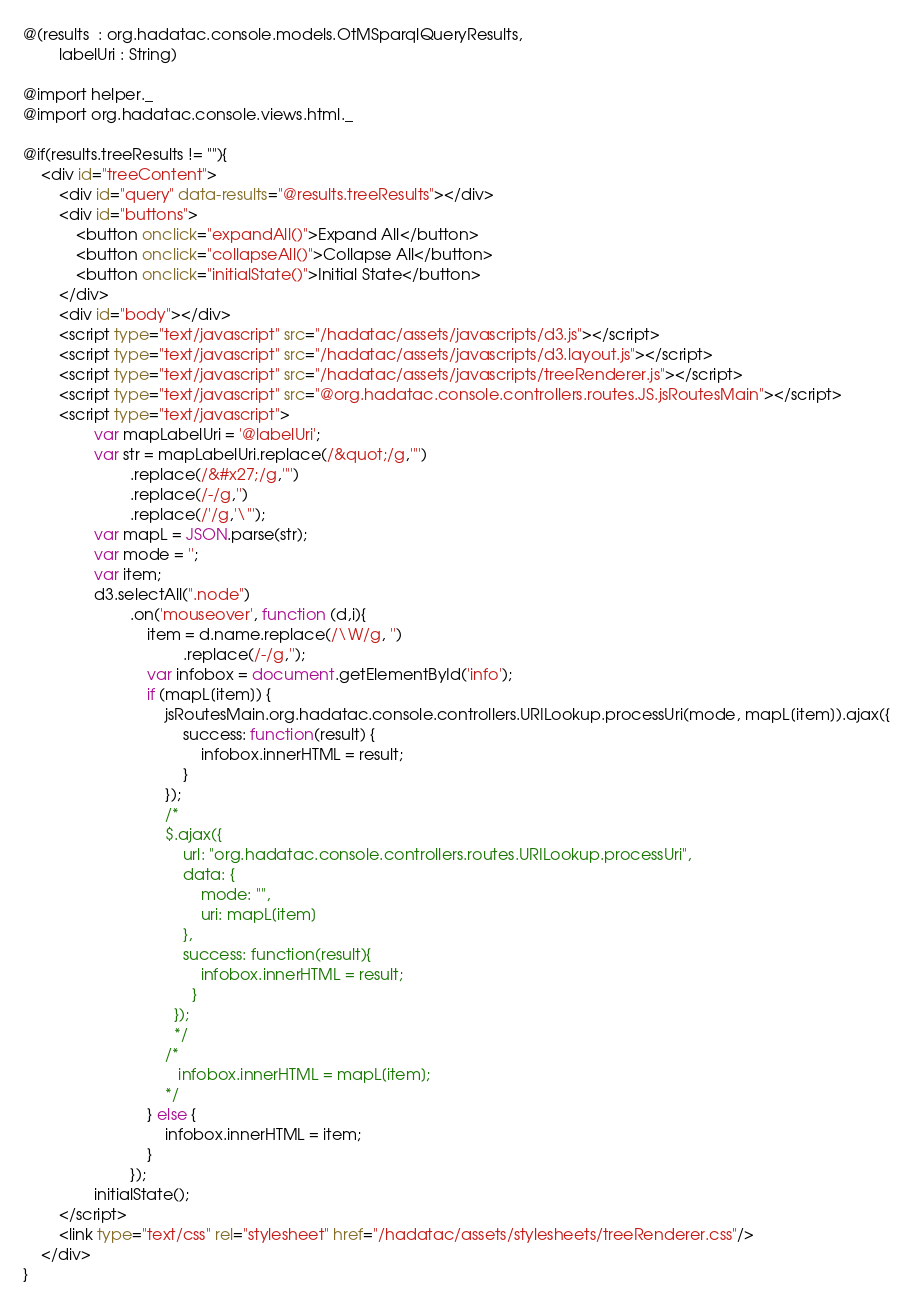<code> <loc_0><loc_0><loc_500><loc_500><_HTML_>@(results  : org.hadatac.console.models.OtMSparqlQueryResults,
        labelUri : String)

@import helper._
@import org.hadatac.console.views.html._

@if(results.treeResults != ""){
    <div id="treeContent">
        <div id="query" data-results="@results.treeResults"></div>
        <div id="buttons">
            <button onclick="expandAll()">Expand All</button>
            <button onclick="collapseAll()">Collapse All</button>
            <button onclick="initialState()">Initial State</button>
        </div>
        <div id="body"></div>
        <script type="text/javascript" src="/hadatac/assets/javascripts/d3.js"></script>
        <script type="text/javascript" src="/hadatac/assets/javascripts/d3.layout.js"></script>
        <script type="text/javascript" src="/hadatac/assets/javascripts/treeRenderer.js"></script>
        <script type="text/javascript" src="@org.hadatac.console.controllers.routes.JS.jsRoutesMain"></script>
        <script type="text/javascript">
                var mapLabelUri = '@labelUri';
                var str = mapLabelUri.replace(/&quot;/g,'"')
                        .replace(/&#x27;/g,'"')
                        .replace(/-/g,'')
                        .replace(/'/g,'\"');
                var mapL = JSON.parse(str);
                var mode = '';
                var item;
                d3.selectAll(".node")
                        .on('mouseover', function (d,i){
                            item = d.name.replace(/\W/g, '')
                                    .replace(/-/g,'');
                            var infobox = document.getElementById('info');
                            if (mapL[item]) {
                                jsRoutesMain.org.hadatac.console.controllers.URILookup.processUri(mode, mapL[item]).ajax({
                                    success: function(result) {
                                        infobox.innerHTML = result;
                                    }
                                });
                                /*
                                $.ajax({
                                    url: "org.hadatac.console.controllers.routes.URILookup.processUri",
                                    data: {
                                        mode: "",
                                        uri: mapL[item]
                                    },
                                    success: function(result){
                                        infobox.innerHTML = result;
                                      }
                                  });
                                  */
                                /*
                                   infobox.innerHTML = mapL[item];
                                */
                            } else {
                                infobox.innerHTML = item;
                            }
                        });
                initialState();
        </script>
        <link type="text/css" rel="stylesheet" href="/hadatac/assets/stylesheets/treeRenderer.css"/>
    </div>
}
</code> 